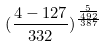<formula> <loc_0><loc_0><loc_500><loc_500>( \frac { 4 - 1 2 7 } { 3 3 2 } ) ^ { \frac { \frac { 5 } { 4 9 2 } } { 3 8 7 } }</formula> 